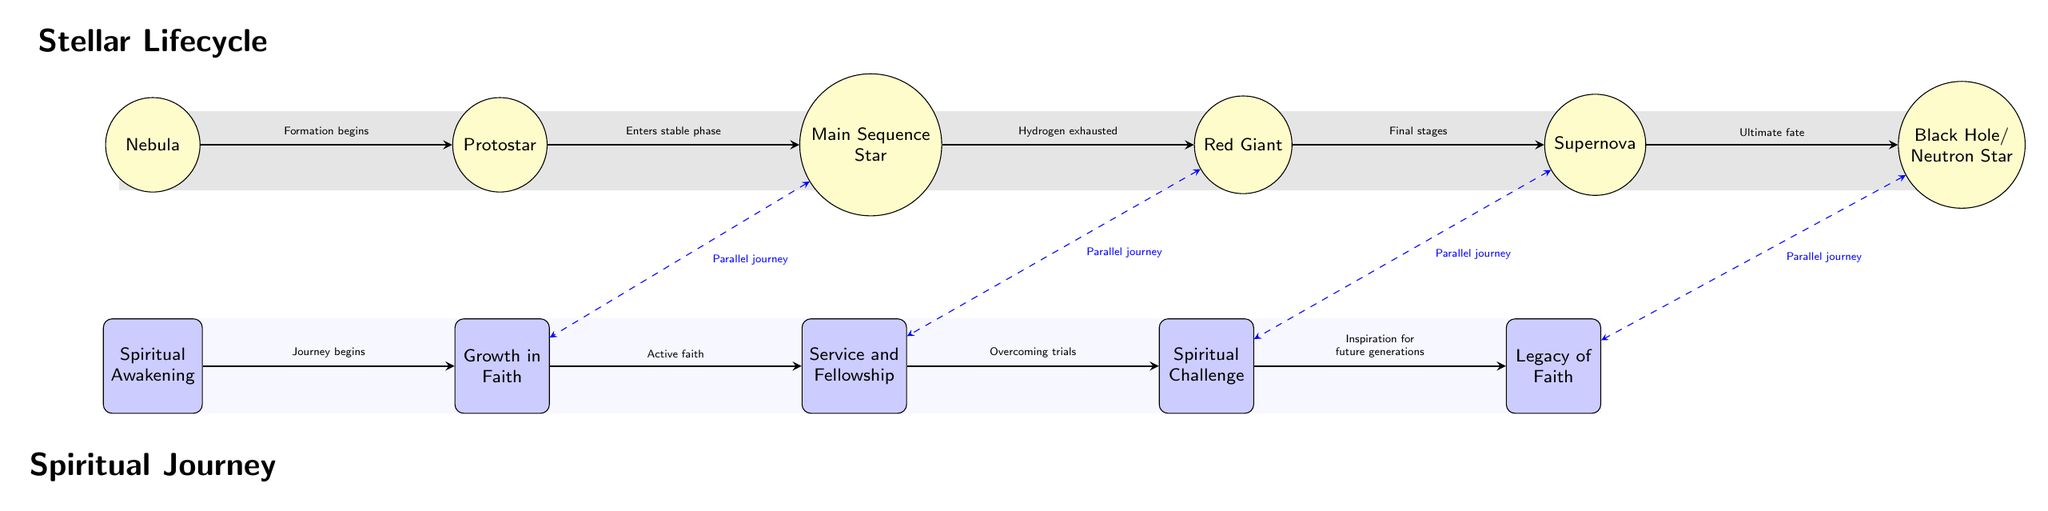What is the first stage of the stellar lifecycle? The first node in the stellar lifecycle is labeled "Nebula," which represents the stage where stars begin to form from clouds of gas and dust.
Answer: Nebula How many nodes are displayed in the spiritual journey section? There are five nodes in the spiritual journey section of the diagram, representing different stages of personal faith development.
Answer: 5 What connects the "Main Sequence Star" and "Growth in Faith"? The connection labeled "Parallel journey" links these two nodes, indicating a relationship between the stability of a star's life and the active faith in one's spiritual journey.
Answer: Parallel journey Which stage follows the "Red Giant"? The node directly to the right of "Red Giant" is "Supernova," indicating that the stellar lifecycle moves into this explosive phase after the red giant stage.
Answer: Supernova What is the last stage of the spiritual journey? The final node in the spiritual journey section is labeled "Legacy of Faith," representing the culmination of one's spiritual journey and the impact one leaves behind.
Answer: Legacy of Faith What transformation occurs from "Protostar" to "Main Sequence Star"? The transformation is described as "Enters stable phase," indicating that the protostar reaches a stability that characterizes the main sequence phase of a star's life.
Answer: Enters stable phase What event occurs during the "Spiritual Challenge" phase? The connection leading from "Spiritual Challenge" to "Legacy of Faith" is labeled "Inspiration for future generations," indicating that challenges inspire others' faith journeys.
Answer: Inspiration for future generations How does the "Supernova" relate to the "Spiritual Challenge"? Both are connected by the "Parallel journey" line, indicating that the explosive transformation of the supernova can be likened to significant spiritual challenges faced in life.
Answer: Parallel journey Which stage represents the initial development in both diagrams? The initial development in both diagrams is represented by "Nebula" in the stellar lifecycle and "Spiritual Awakening" in the spiritual journey, indicating the beginning of formation.
Answer: Nebula, Spiritual Awakening 